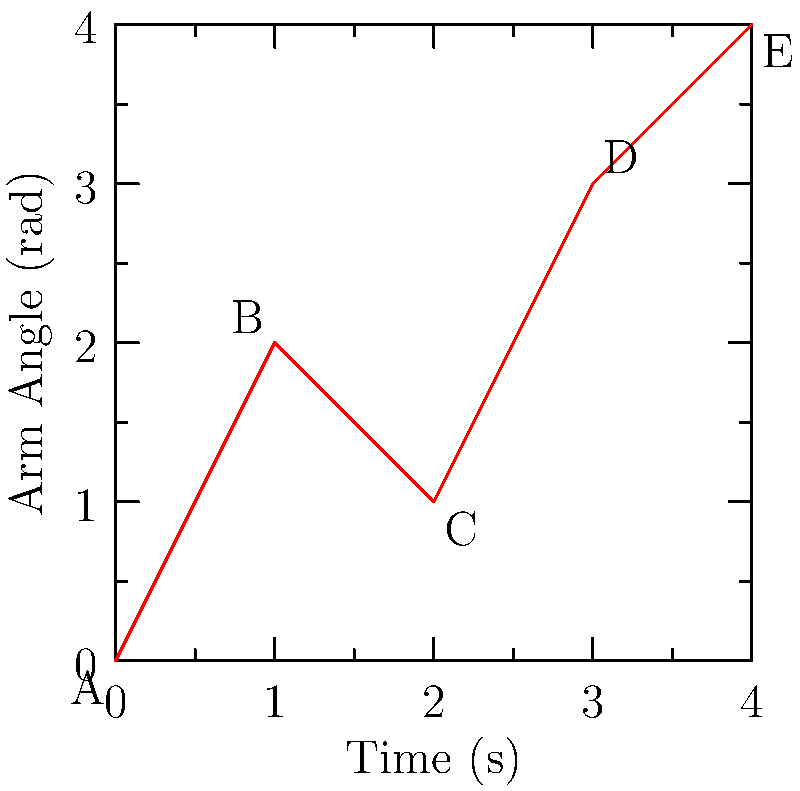The graph above shows the arm angle of a pitcher during a fastball throw over time. At which point in the motion does the pitcher's arm experience the highest angular acceleration? To determine the point of highest angular acceleration, we need to analyze the rate of change of angular velocity. Angular acceleration is the second derivative of position with respect to time.

1. First, let's look at the slope between each pair of points, which represents angular velocity:
   A to B: Increasing (positive slope)
   B to C: Decreasing (negative slope)
   C to D: Increasing (positive slope)
   D to E: Increasing (positive slope, but less steep than C to D)

2. Now, we need to find where the change in angular velocity is greatest:
   A to B to C: Velocity changes from positive to negative (high acceleration)
   C to D to E: Velocity changes from negative to positive, then decreases (high acceleration, but less than A to B to C)

3. The greatest change in velocity occurs at point B, where the arm goes from increasing angle (wind-up) to decreasing angle (forward motion).

4. This rapid change in direction at point B indicates the highest angular acceleration.
Answer: Point B 